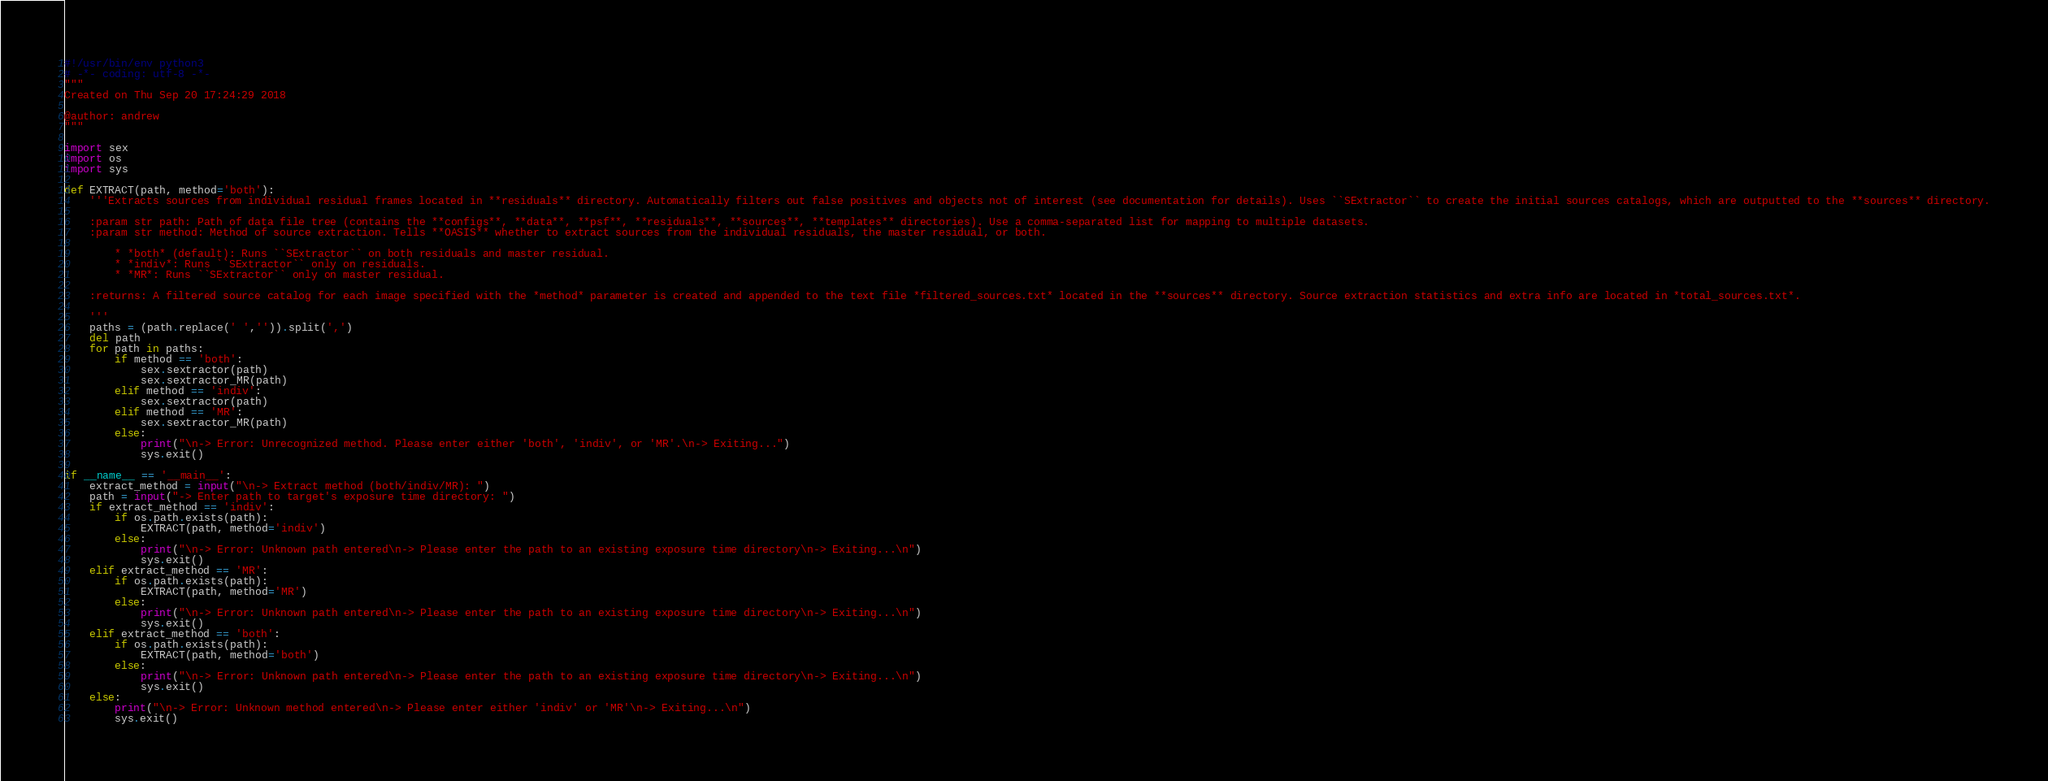Convert code to text. <code><loc_0><loc_0><loc_500><loc_500><_Python_>#!/usr/bin/env python3
# -*- coding: utf-8 -*-
"""
Created on Thu Sep 20 17:24:29 2018

@author: andrew
"""

import sex
import os
import sys

def EXTRACT(path, method='both'):
    '''Extracts sources from individual residual frames located in **residuals** directory. Automatically filters out false positives and objects not of interest (see documentation for details). Uses ``SExtractor`` to create the initial sources catalogs, which are outputted to the **sources** directory.
    
    :param str path: Path of data file tree (contains the **configs**, **data**, **psf**, **residuals**, **sources**, **templates** directories). Use a comma-separated list for mapping to multiple datasets.
    :param str method: Method of source extraction. Tells **OASIS** whether to extract sources from the individual residuals, the master residual, or both.
        
        * *both* (default): Runs ``SExtractor`` on both residuals and master residual.
        * *indiv*: Runs ``SExtractor`` only on residuals.
        * *MR*: Runs ``SExtractor`` only on master residual.
    
    :returns: A filtered source catalog for each image specified with the *method* parameter is created and appended to the text file *filtered_sources.txt* located in the **sources** directory. Source extraction statistics and extra info are located in *total_sources.txt*.
    
    '''
    paths = (path.replace(' ','')).split(',')
    del path
    for path in paths:
        if method == 'both':
            sex.sextractor(path)
            sex.sextractor_MR(path)
        elif method == 'indiv':
            sex.sextractor(path)
        elif method == 'MR':
            sex.sextractor_MR(path)
        else:
            print("\n-> Error: Unrecognized method. Please enter either 'both', 'indiv', or 'MR'.\n-> Exiting...")
            sys.exit()

if __name__ == '__main__':
    extract_method = input("\n-> Extract method (both/indiv/MR): ")
    path = input("-> Enter path to target's exposure time directory: ")
    if extract_method == 'indiv':
        if os.path.exists(path):
            EXTRACT(path, method='indiv')
        else:
            print("\n-> Error: Unknown path entered\n-> Please enter the path to an existing exposure time directory\n-> Exiting...\n")
            sys.exit()
    elif extract_method == 'MR':
        if os.path.exists(path):
            EXTRACT(path, method='MR')
        else:
            print("\n-> Error: Unknown path entered\n-> Please enter the path to an existing exposure time directory\n-> Exiting...\n")
            sys.exit()
    elif extract_method == 'both':
        if os.path.exists(path):
            EXTRACT(path, method='both')
        else:
            print("\n-> Error: Unknown path entered\n-> Please enter the path to an existing exposure time directory\n-> Exiting...\n")
            sys.exit()
    else:
        print("\n-> Error: Unknown method entered\n-> Please enter either 'indiv' or 'MR'\n-> Exiting...\n")
        sys.exit()</code> 